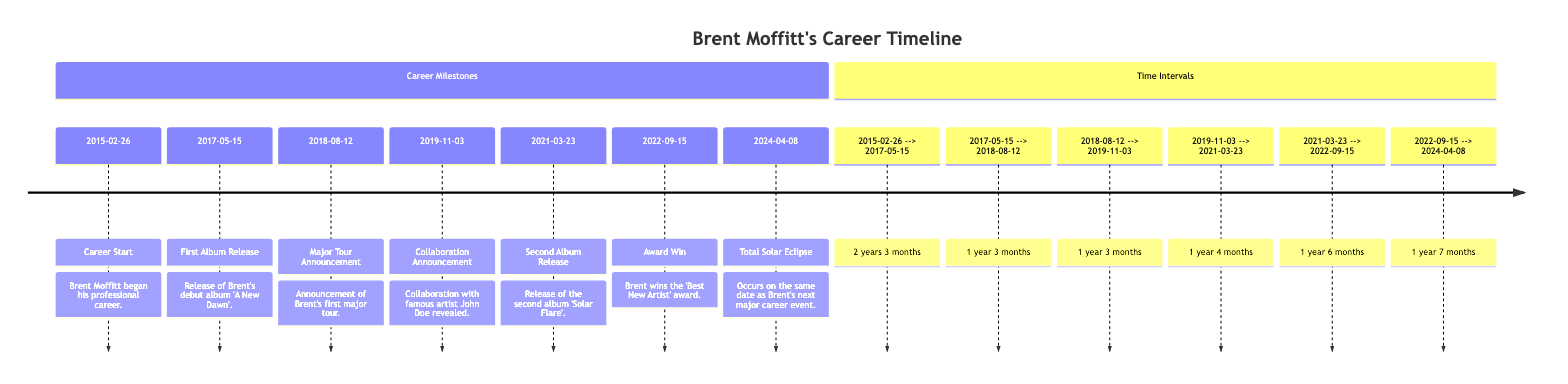what is the date of Brent Moffitt's career start? The timeline shows that Brent Moffitt began his professional career on February 26, 2015.
Answer: February 26, 2015 how many major albums has Brent Moffitt released by 2024? Referring to the timeline, Brent has released two major albums: 'A New Dawn' in 2017 and 'Solar Flare' in 2021.
Answer: 2 what event occurred on the same date as the total solar eclipse in 2024? The diagram indicates that a major career event for Brent occurs on April 8, 2024, which is the date of the total solar eclipse.
Answer: Major career event what is the time interval between Brent's first album release and his first major tour announcement? By checking the timeline, the interval is from May 15, 2017, to August 12, 2018, which totals 1 year and 3 months.
Answer: 1 year 3 months how many months passed between Brent's collaboration announcement and his second album release? From the diagram, the collaboration announcement was on November 3, 2019, and the second album release was on March 23, 2021. The time interval is 1 year and 4 months, which is equivalent to 16 months.
Answer: 16 months which award did Brent win in September 2022? According to the timeline, Brent won the 'Best New Artist' award on September 15, 2022.
Answer: Best New Artist which event in Brent’s career took the longest time to follow the previous event? Observing the intervals closely, the longest time is between the second album release on March 23, 2021, and the award win on September 15, 2022, which is 1 year and 6 months.
Answer: 1 year 6 months how many years are there between Brent's career start and his first album release? The timeline shows the interval from February 26, 2015, to May 15, 2017, which calculates to 2 years and 3 months.
Answer: 2 years 3 months when was the major tour announcement made? The diagram marks the major tour announcement as occurring on August 12, 2018.
Answer: August 12, 2018 